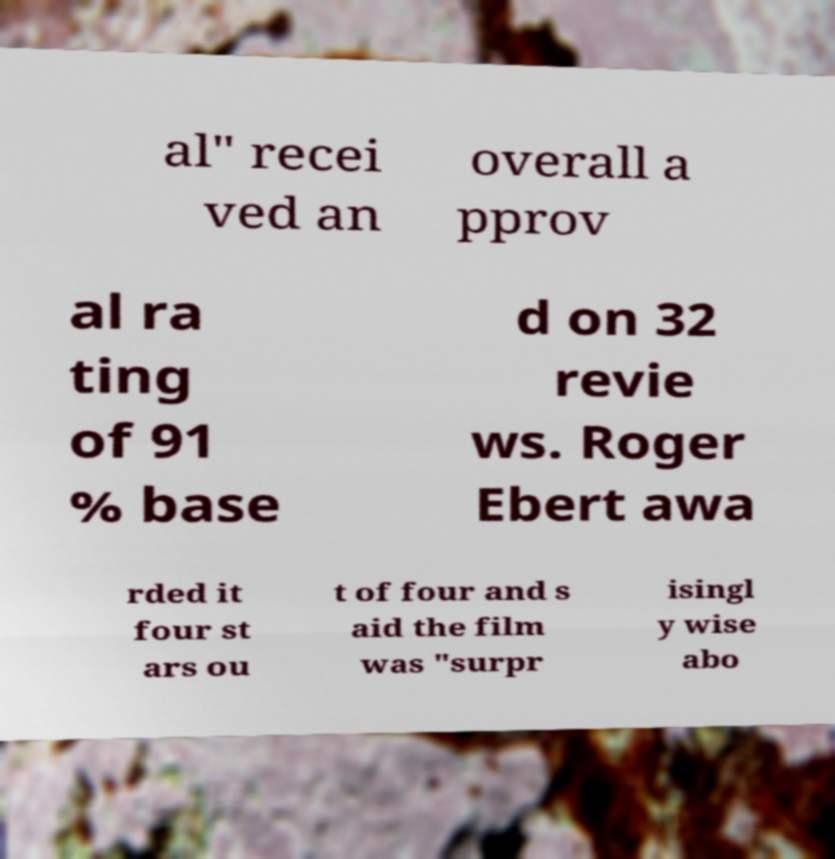Can you accurately transcribe the text from the provided image for me? al" recei ved an overall a pprov al ra ting of 91 % base d on 32 revie ws. Roger Ebert awa rded it four st ars ou t of four and s aid the film was "surpr isingl y wise abo 